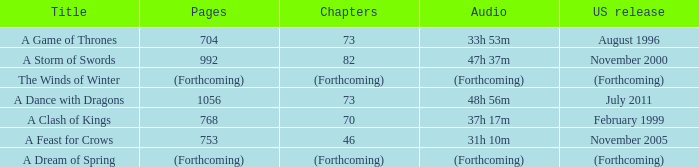Which US release has 704 pages? August 1996. 